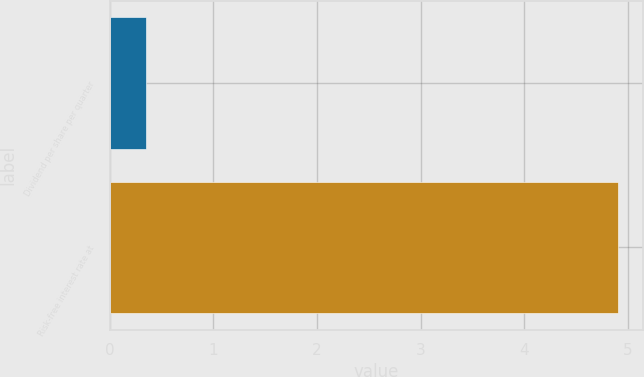<chart> <loc_0><loc_0><loc_500><loc_500><bar_chart><fcel>Dividend per share per quarter<fcel>Risk-free interest rate at<nl><fcel>0.35<fcel>4.9<nl></chart> 